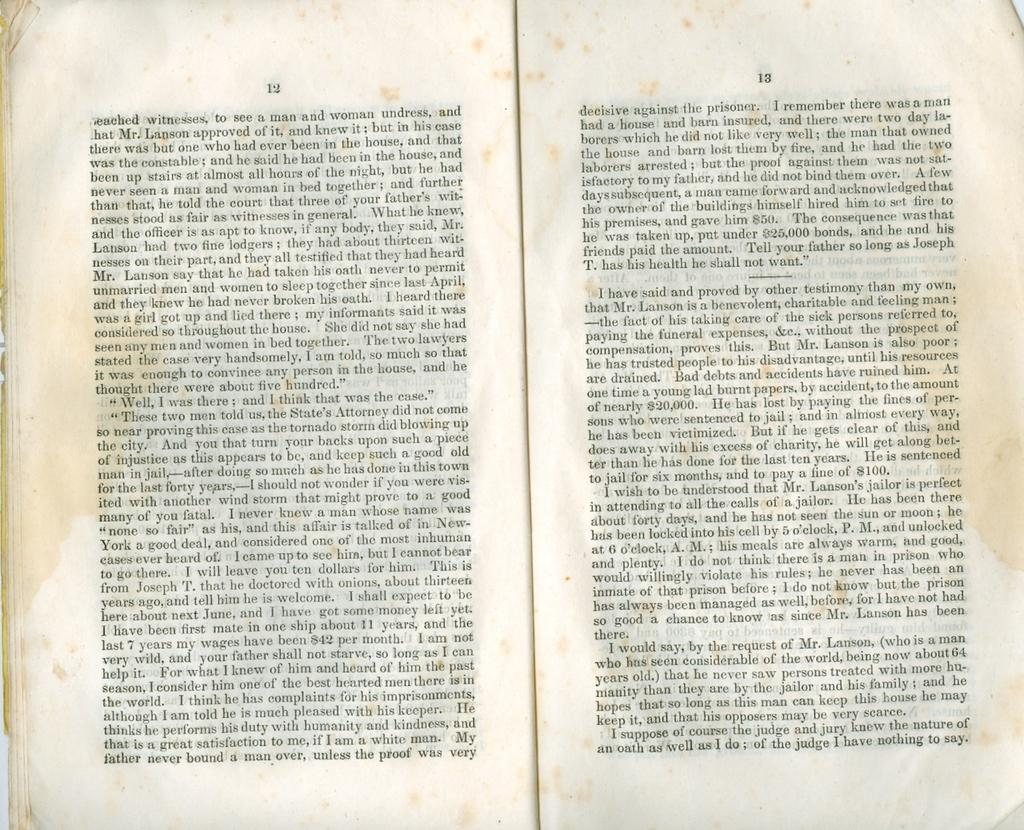<image>
Render a clear and concise summary of the photo. Stained pages 12 and 13 of an old text discuss a Mr. Lanson. 